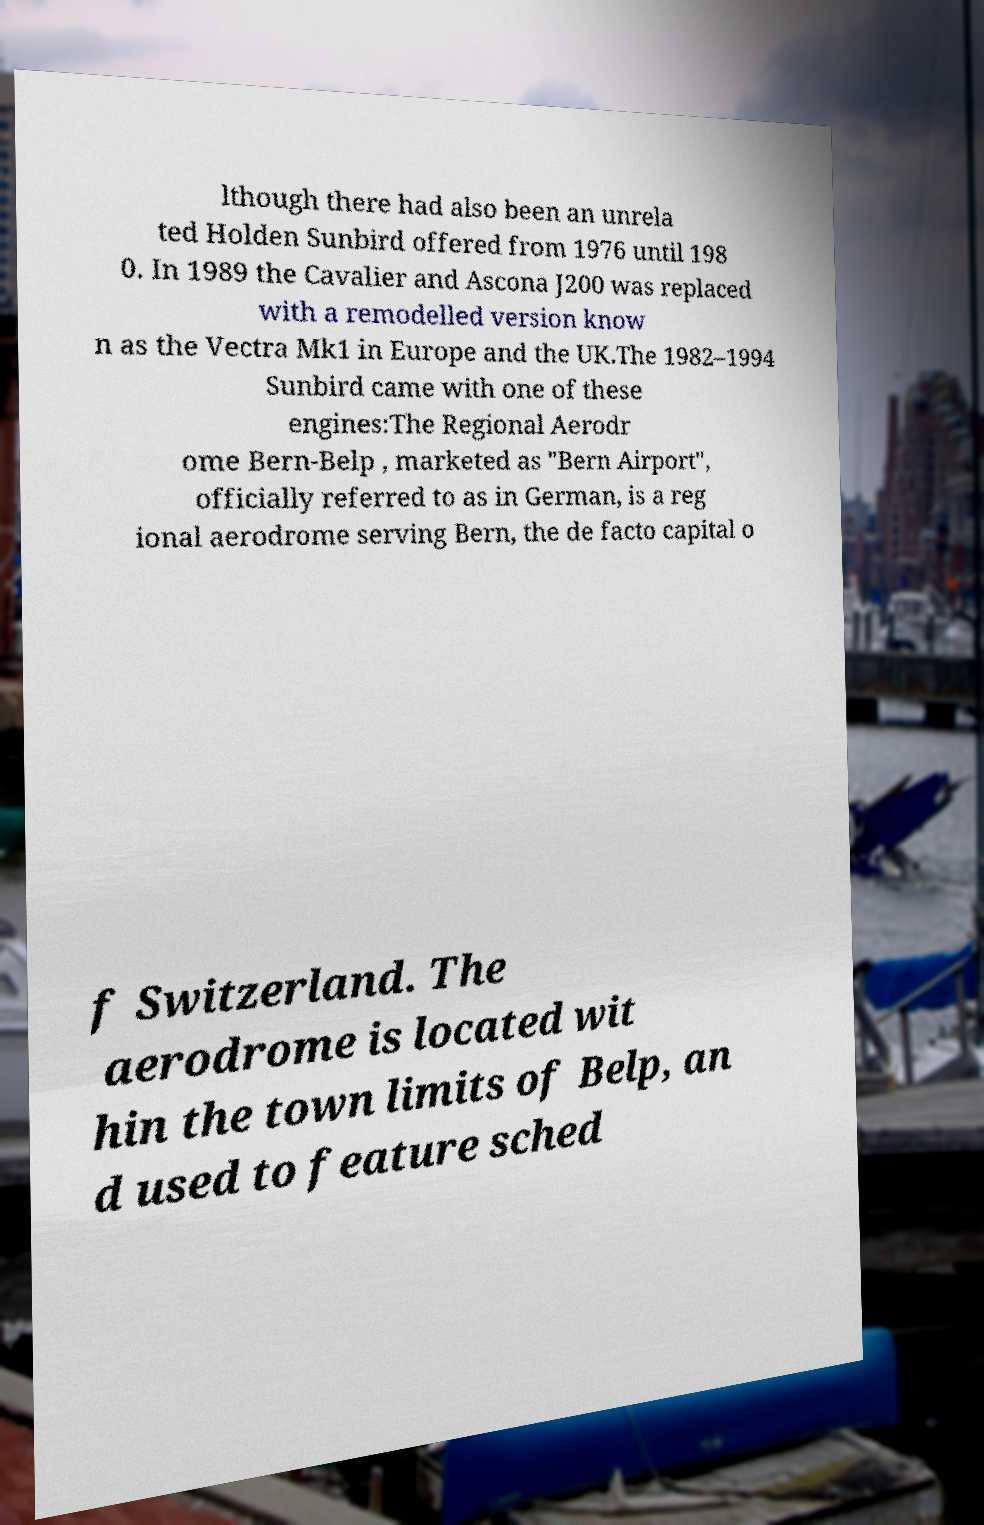I need the written content from this picture converted into text. Can you do that? lthough there had also been an unrela ted Holden Sunbird offered from 1976 until 198 0. In 1989 the Cavalier and Ascona J200 was replaced with a remodelled version know n as the Vectra Mk1 in Europe and the UK.The 1982–1994 Sunbird came with one of these engines:The Regional Aerodr ome Bern-Belp , marketed as "Bern Airport", officially referred to as in German, is a reg ional aerodrome serving Bern, the de facto capital o f Switzerland. The aerodrome is located wit hin the town limits of Belp, an d used to feature sched 